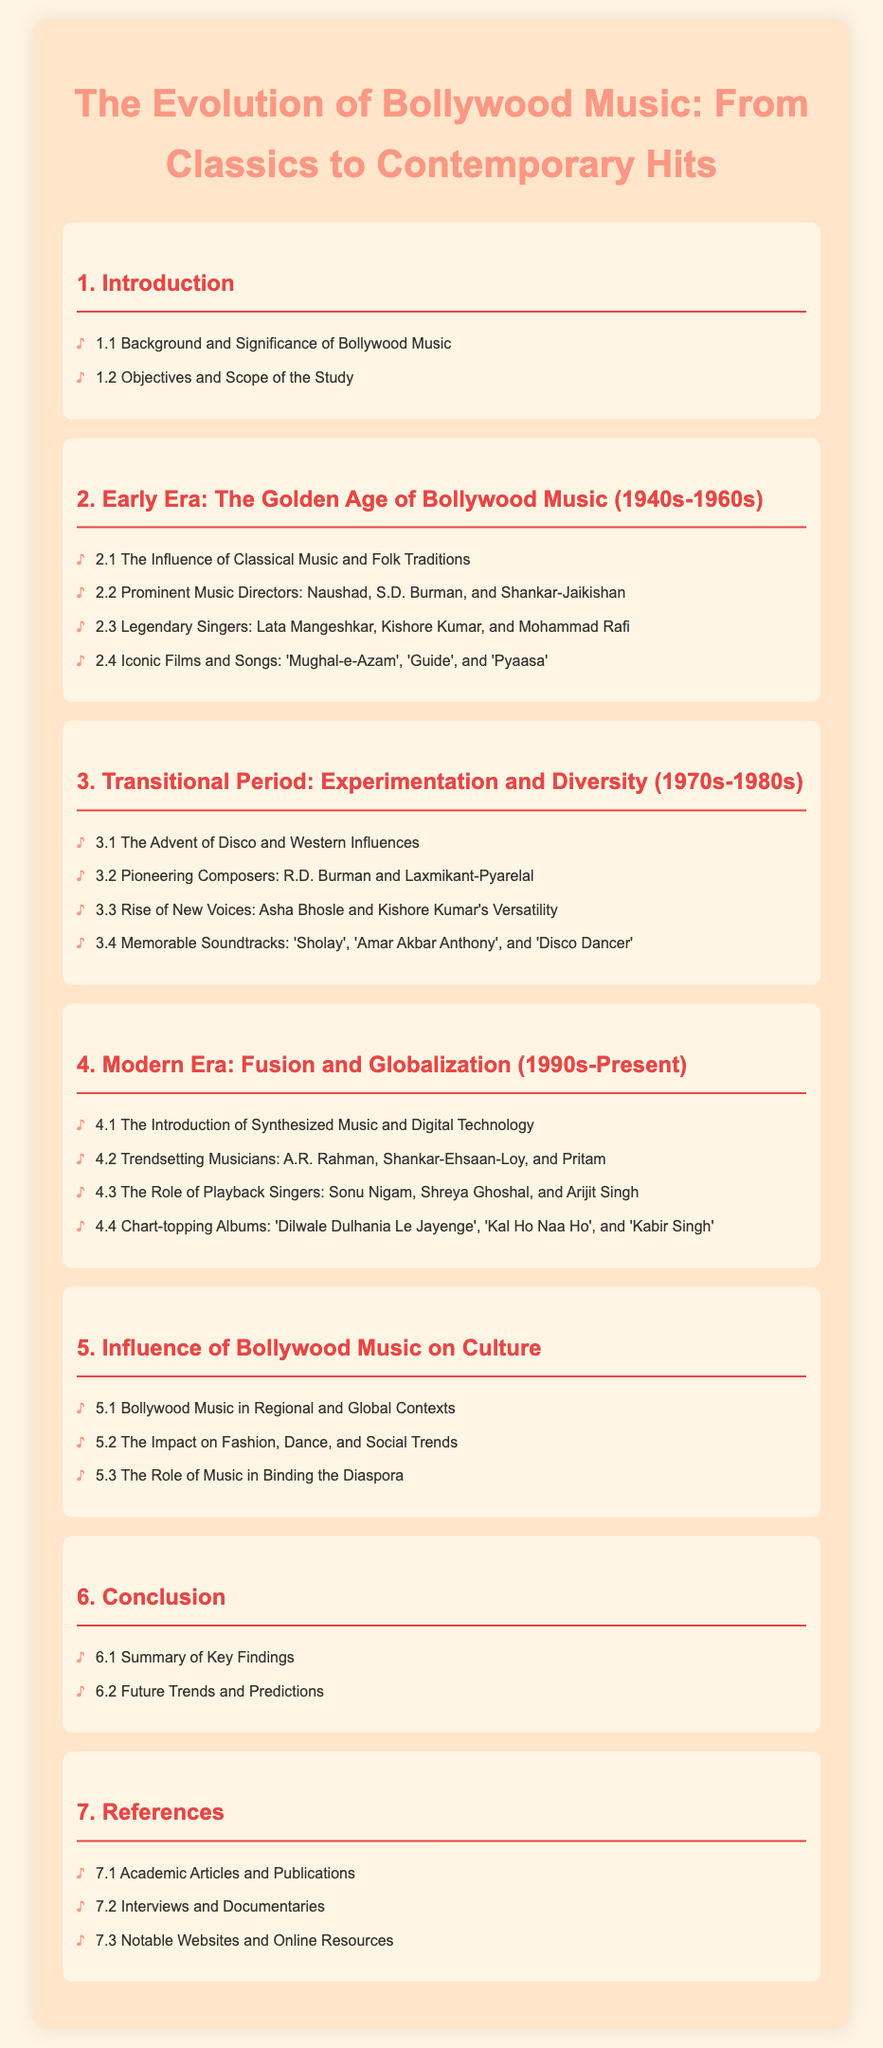What is the title of the document? The title of the document is provided at the beginning and summarizes its focus on the evolution of Bollywood music.
Answer: The Evolution of Bollywood Music: From Classics to Contemporary Hits Who are the legendary singers mentioned in the early era? The legendary singers are listed in the Early Era section, specifically in 2.3.
Answer: Lata Mangeshkar, Kishore Kumar, Mohammad Rafi Which decade marks the transitional period of Bollywood music? The transitional period is defined in the document and specifically identifies the decades involved.
Answer: 1970s-1980s What technological advancement is mentioned in the modern era? The modern era section includes specific details about technological changes in Bollywood music.
Answer: Synthesized Music and Digital Technology Who is noted as a trendsetting musician from the modern era? The modern era highlights specific influential musicians, found under 4.2.
Answer: A.R. Rahman What influence does Bollywood music have on fashion? The influence is discussed in section 5.2 of the document, addressing cultural impacts.
Answer: The Impact on Fashion How many sections are there in the document? The number of sections is revealed by counting the main headings in the table of contents.
Answer: 7 What is the focus of section 1.2 in the document? Section 1.2 outlines the objectives and scope, mentioned in the first section.
Answer: Objectives and Scope of the Study Which iconic film is mentioned in the early era? The document lists specific films that are pivotal in the Early Era section.
Answer: Mughal-e-Azam 